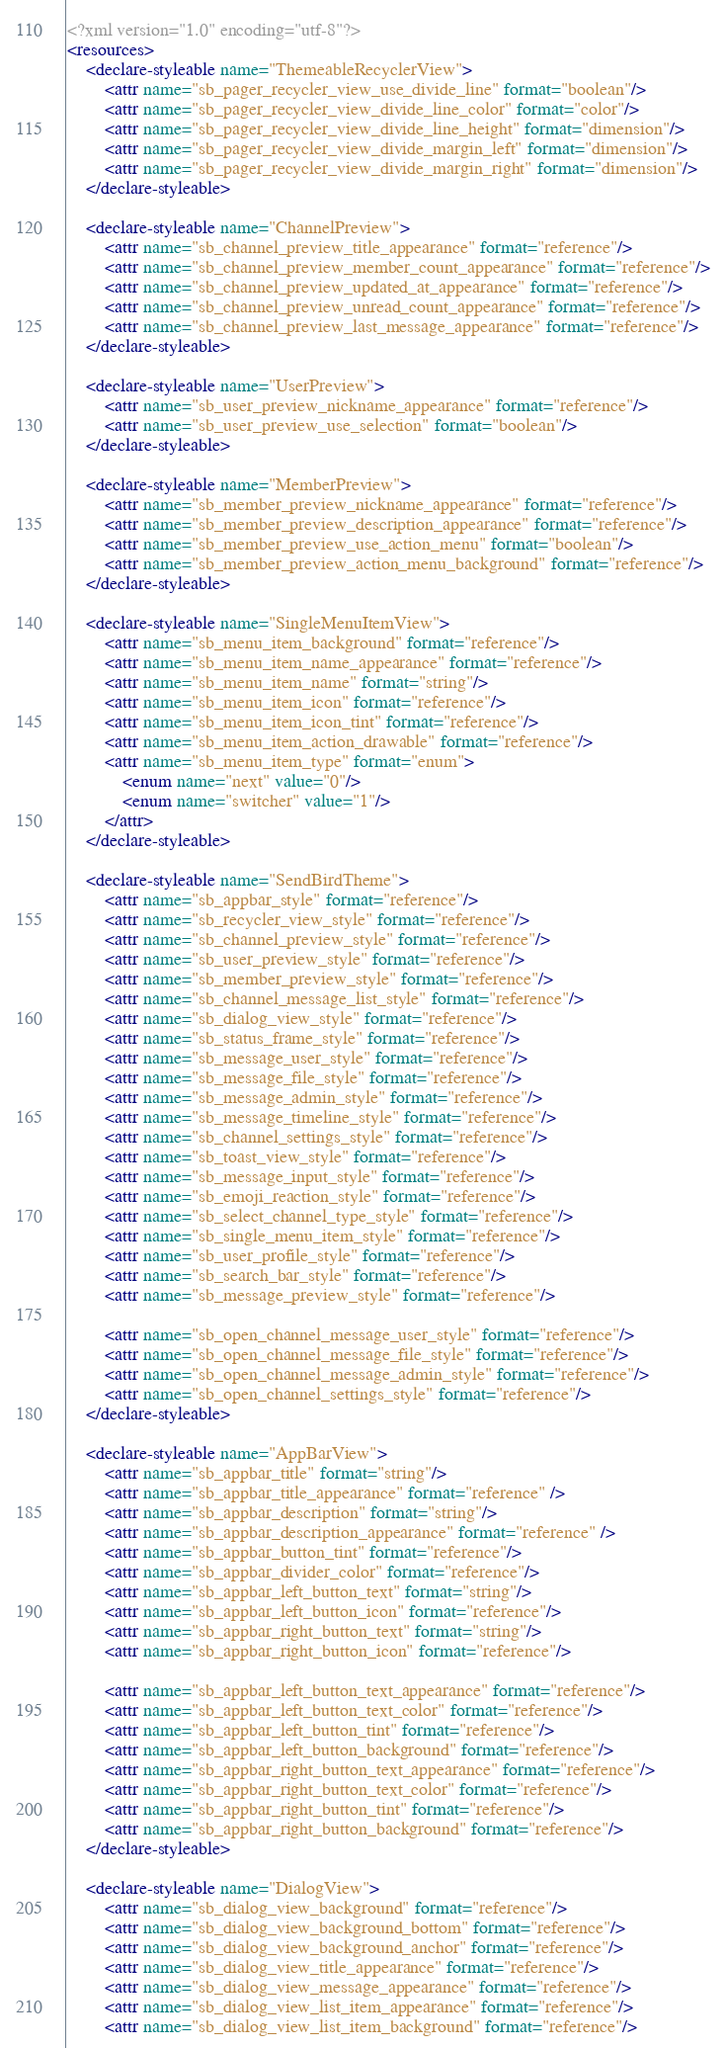<code> <loc_0><loc_0><loc_500><loc_500><_XML_><?xml version="1.0" encoding="utf-8"?>
<resources>
    <declare-styleable name="ThemeableRecyclerView">
        <attr name="sb_pager_recycler_view_use_divide_line" format="boolean"/>
        <attr name="sb_pager_recycler_view_divide_line_color" format="color"/>
        <attr name="sb_pager_recycler_view_divide_line_height" format="dimension"/>
        <attr name="sb_pager_recycler_view_divide_margin_left" format="dimension"/>
        <attr name="sb_pager_recycler_view_divide_margin_right" format="dimension"/>
    </declare-styleable>

    <declare-styleable name="ChannelPreview">
        <attr name="sb_channel_preview_title_appearance" format="reference"/>
        <attr name="sb_channel_preview_member_count_appearance" format="reference"/>
        <attr name="sb_channel_preview_updated_at_appearance" format="reference"/>
        <attr name="sb_channel_preview_unread_count_appearance" format="reference"/>
        <attr name="sb_channel_preview_last_message_appearance" format="reference"/>
    </declare-styleable>

    <declare-styleable name="UserPreview">
        <attr name="sb_user_preview_nickname_appearance" format="reference"/>
        <attr name="sb_user_preview_use_selection" format="boolean"/>
    </declare-styleable>

    <declare-styleable name="MemberPreview">
        <attr name="sb_member_preview_nickname_appearance" format="reference"/>
        <attr name="sb_member_preview_description_appearance" format="reference"/>
        <attr name="sb_member_preview_use_action_menu" format="boolean"/>
        <attr name="sb_member_preview_action_menu_background" format="reference"/>
    </declare-styleable>

    <declare-styleable name="SingleMenuItemView">
        <attr name="sb_menu_item_background" format="reference"/>
        <attr name="sb_menu_item_name_appearance" format="reference"/>
        <attr name="sb_menu_item_name" format="string"/>
        <attr name="sb_menu_item_icon" format="reference"/>
        <attr name="sb_menu_item_icon_tint" format="reference"/>
        <attr name="sb_menu_item_action_drawable" format="reference"/>
        <attr name="sb_menu_item_type" format="enum">
            <enum name="next" value="0"/>
            <enum name="switcher" value="1"/>
        </attr>
    </declare-styleable>

    <declare-styleable name="SendBirdTheme">
        <attr name="sb_appbar_style" format="reference"/>
        <attr name="sb_recycler_view_style" format="reference"/>
        <attr name="sb_channel_preview_style" format="reference"/>
        <attr name="sb_user_preview_style" format="reference"/>
        <attr name="sb_member_preview_style" format="reference"/>
        <attr name="sb_channel_message_list_style" format="reference"/>
        <attr name="sb_dialog_view_style" format="reference"/>
        <attr name="sb_status_frame_style" format="reference"/>
        <attr name="sb_message_user_style" format="reference"/>
        <attr name="sb_message_file_style" format="reference"/>
        <attr name="sb_message_admin_style" format="reference"/>
        <attr name="sb_message_timeline_style" format="reference"/>
        <attr name="sb_channel_settings_style" format="reference"/>
        <attr name="sb_toast_view_style" format="reference"/>
        <attr name="sb_message_input_style" format="reference"/>
        <attr name="sb_emoji_reaction_style" format="reference"/>
        <attr name="sb_select_channel_type_style" format="reference"/>
        <attr name="sb_single_menu_item_style" format="reference"/>
        <attr name="sb_user_profile_style" format="reference"/>
        <attr name="sb_search_bar_style" format="reference"/>
        <attr name="sb_message_preview_style" format="reference"/>

        <attr name="sb_open_channel_message_user_style" format="reference"/>
        <attr name="sb_open_channel_message_file_style" format="reference"/>
        <attr name="sb_open_channel_message_admin_style" format="reference"/>
        <attr name="sb_open_channel_settings_style" format="reference"/>
    </declare-styleable>

    <declare-styleable name="AppBarView">
        <attr name="sb_appbar_title" format="string"/>
        <attr name="sb_appbar_title_appearance" format="reference" />
        <attr name="sb_appbar_description" format="string"/>
        <attr name="sb_appbar_description_appearance" format="reference" />
        <attr name="sb_appbar_button_tint" format="reference"/>
        <attr name="sb_appbar_divider_color" format="reference"/>
        <attr name="sb_appbar_left_button_text" format="string"/>
        <attr name="sb_appbar_left_button_icon" format="reference"/>
        <attr name="sb_appbar_right_button_text" format="string"/>
        <attr name="sb_appbar_right_button_icon" format="reference"/>

        <attr name="sb_appbar_left_button_text_appearance" format="reference"/>
        <attr name="sb_appbar_left_button_text_color" format="reference"/>
        <attr name="sb_appbar_left_button_tint" format="reference"/>
        <attr name="sb_appbar_left_button_background" format="reference"/>
        <attr name="sb_appbar_right_button_text_appearance" format="reference"/>
        <attr name="sb_appbar_right_button_text_color" format="reference"/>
        <attr name="sb_appbar_right_button_tint" format="reference"/>
        <attr name="sb_appbar_right_button_background" format="reference"/>
    </declare-styleable>

    <declare-styleable name="DialogView">
        <attr name="sb_dialog_view_background" format="reference"/>
        <attr name="sb_dialog_view_background_bottom" format="reference"/>
        <attr name="sb_dialog_view_background_anchor" format="reference"/>
        <attr name="sb_dialog_view_title_appearance" format="reference"/>
        <attr name="sb_dialog_view_message_appearance" format="reference"/>
        <attr name="sb_dialog_view_list_item_appearance" format="reference"/>
        <attr name="sb_dialog_view_list_item_background" format="reference"/></code> 